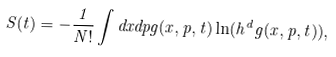Convert formula to latex. <formula><loc_0><loc_0><loc_500><loc_500>S ( t ) = - \frac { 1 } { N ! } \int d x d p g ( x , p , t ) \ln ( h ^ { d } g ( x , p , t ) ) ,</formula> 